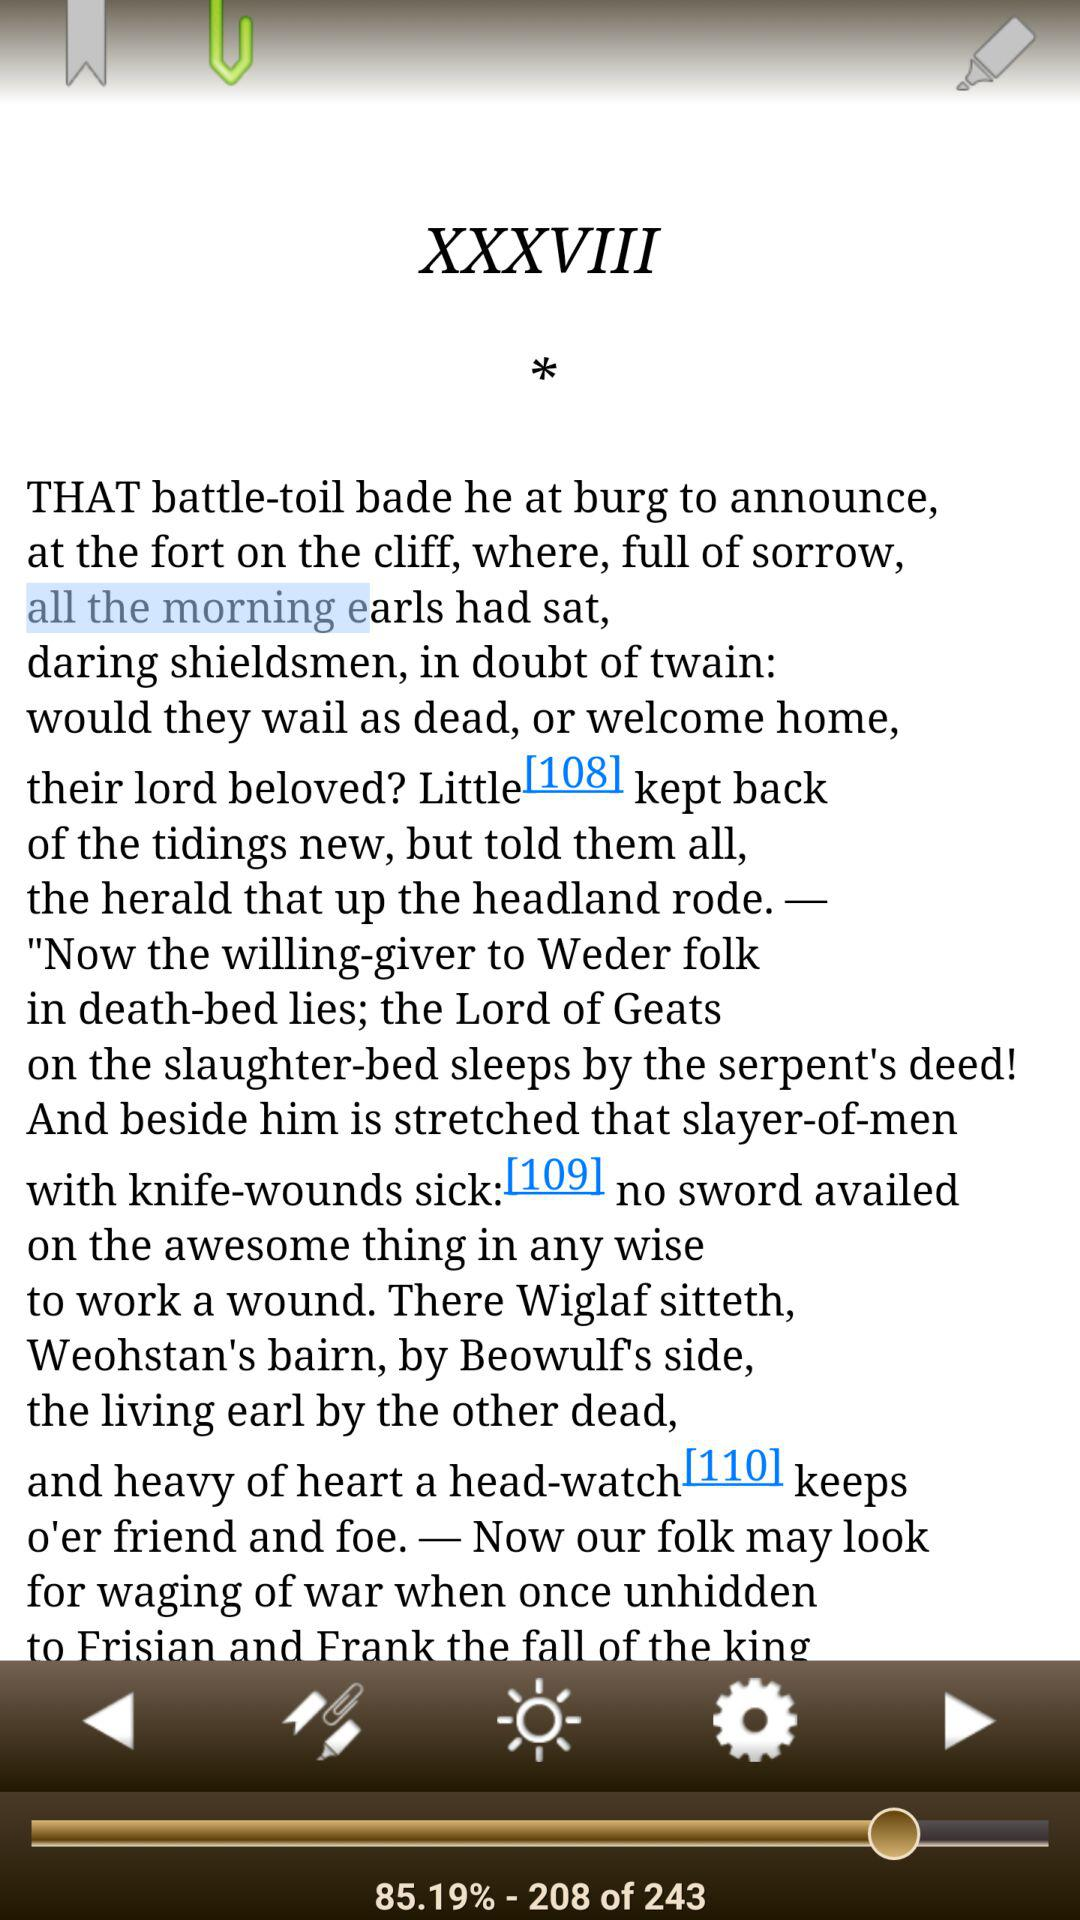How many percent of the text is completed?
Answer the question using a single word or phrase. 85.19% 